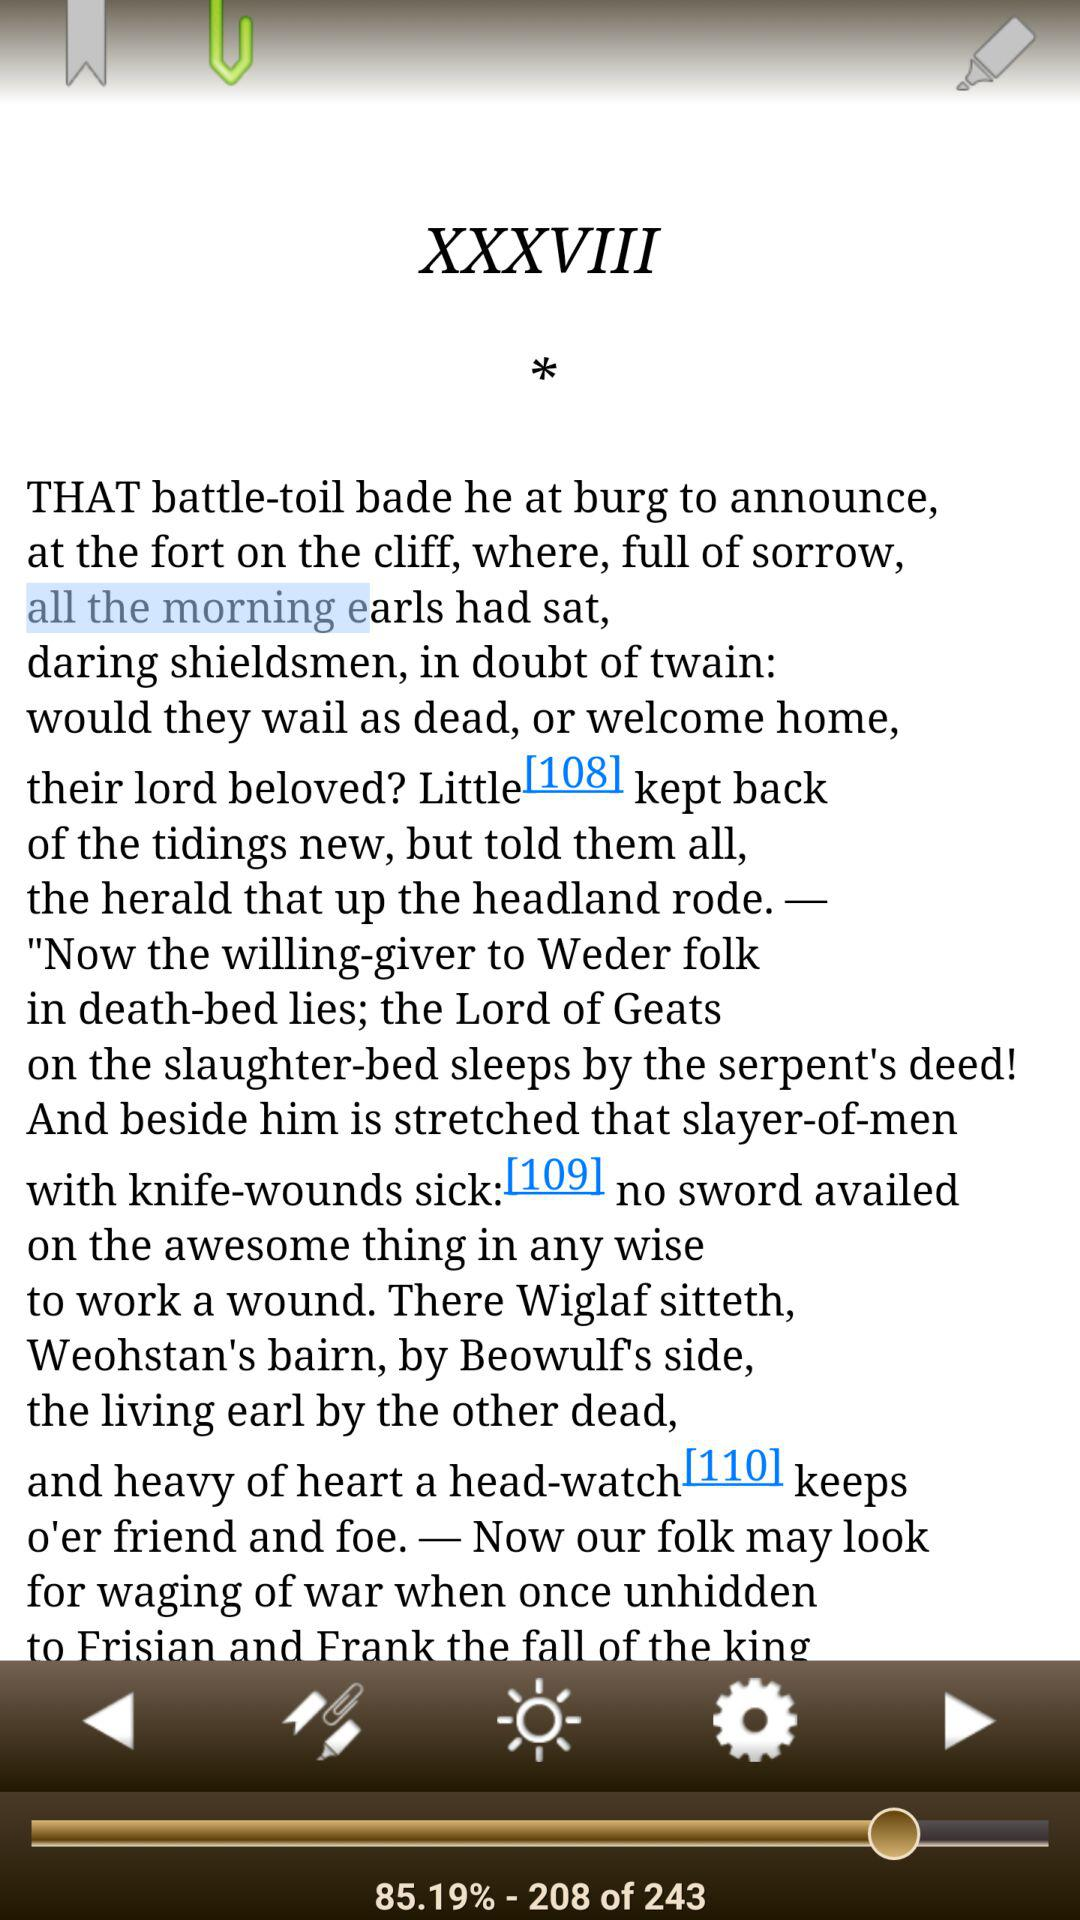How many percent of the text is completed?
Answer the question using a single word or phrase. 85.19% 